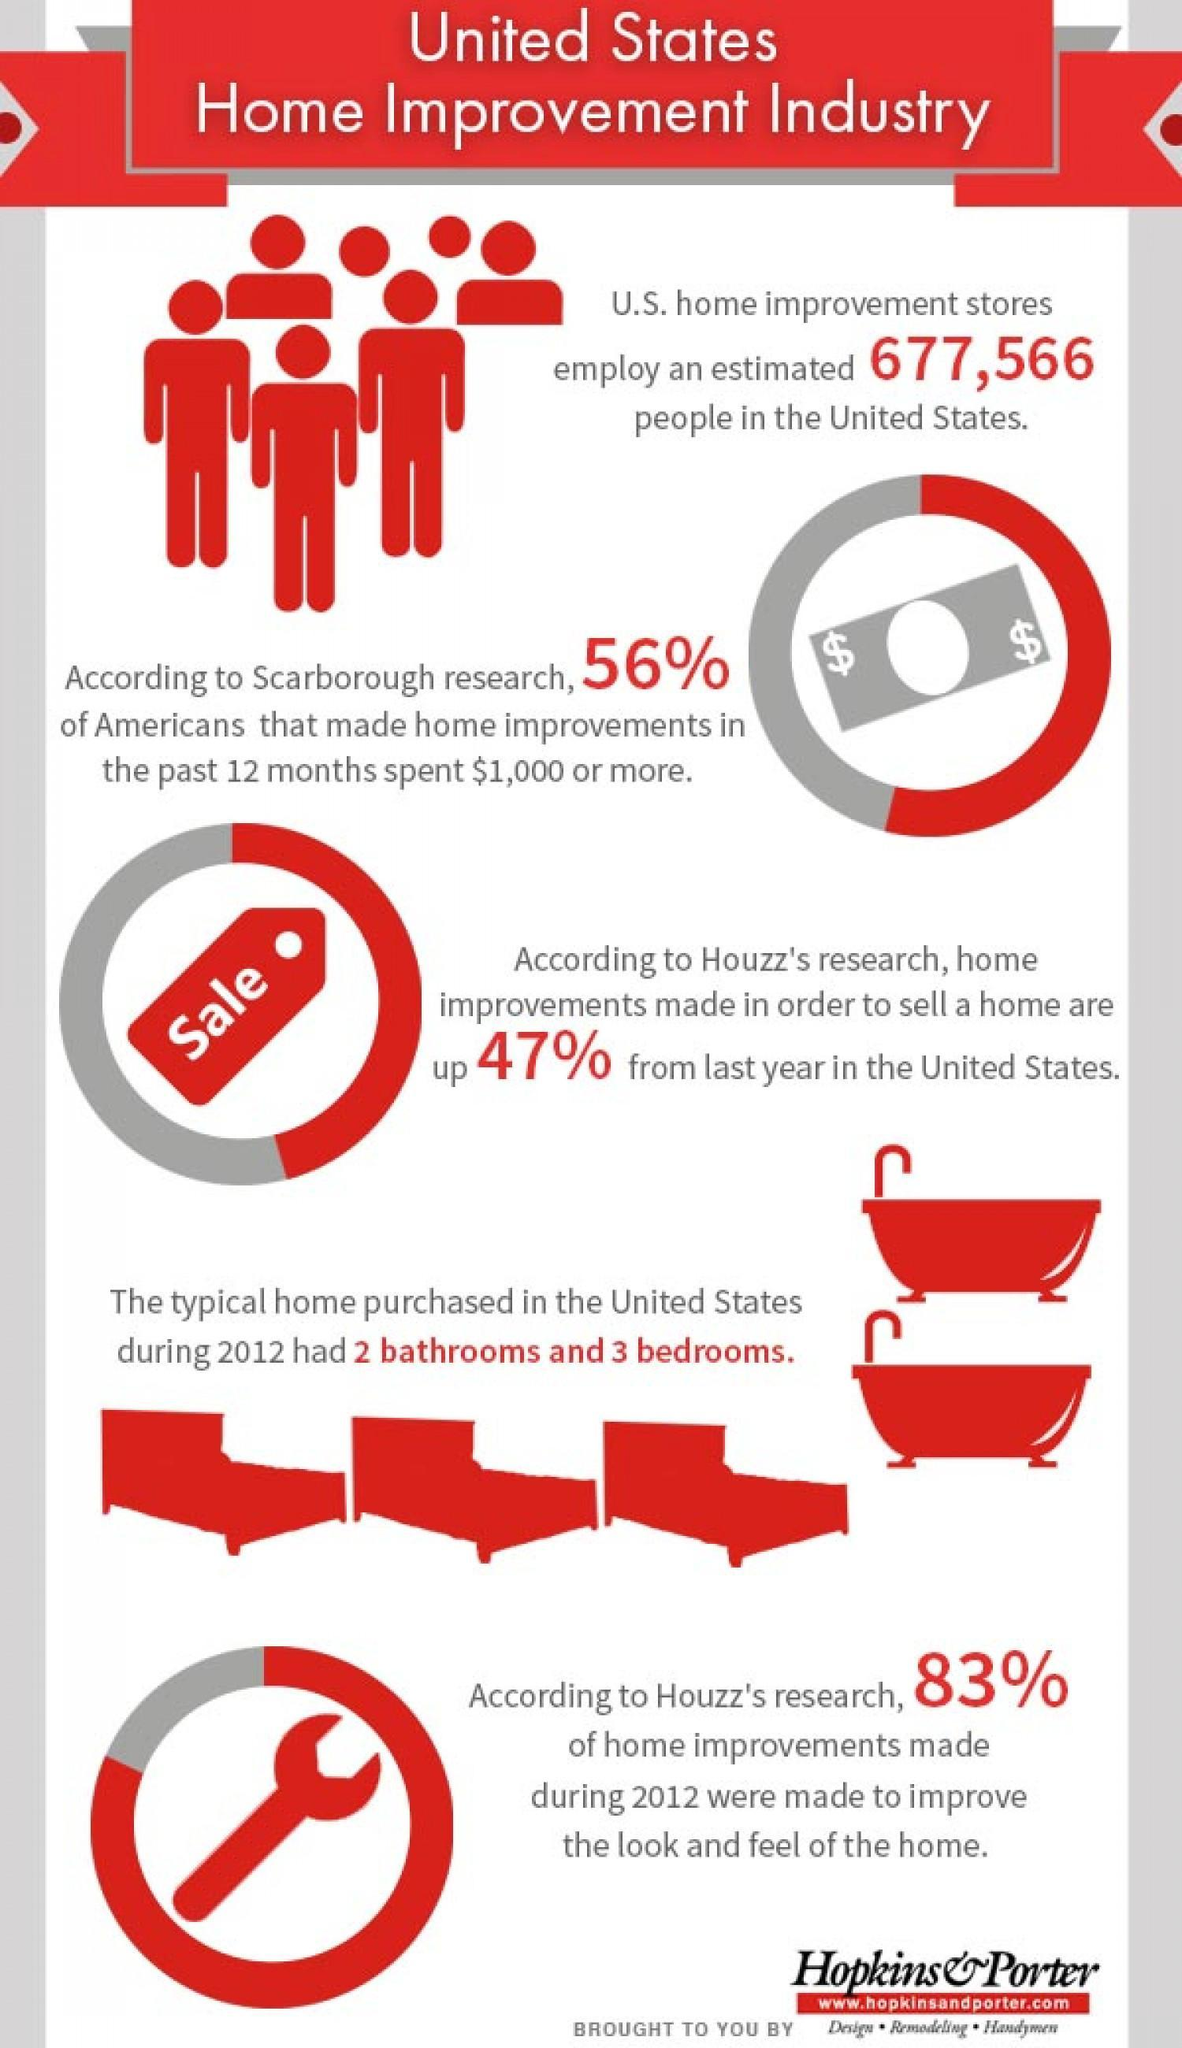Whose research showed increase in home improvements in US?
Answer the question with a short phrase. Houzz's 